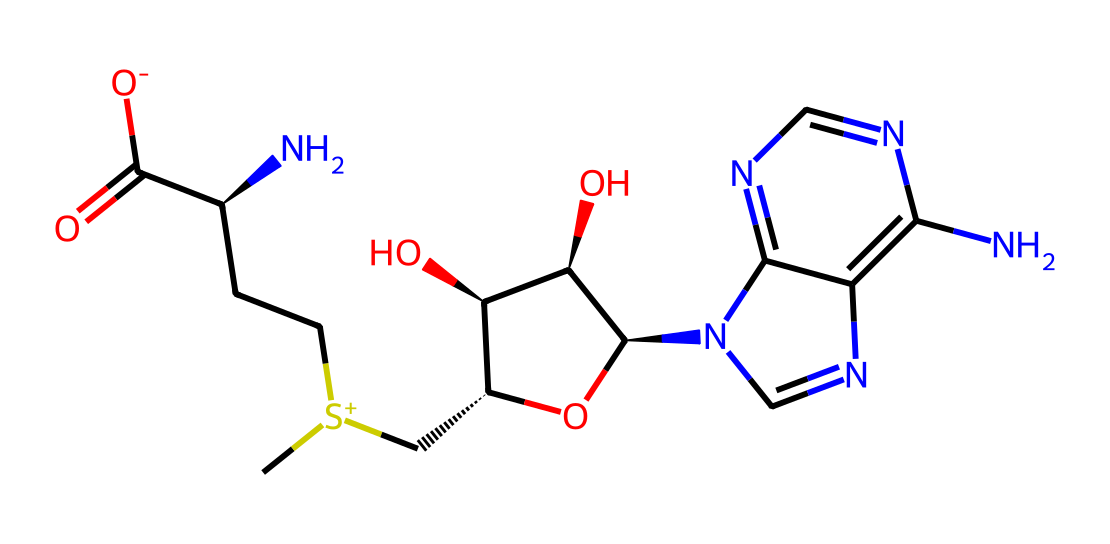What is the number of carbon atoms in S-Adenosyl methionine? By analyzing the provided SMILES representation, we can identify the carbon atoms (C). Counting each instance in the structure leads to a total of 12 carbon atoms.
Answer: 12 How many nitrogen atoms are present in the molecule? The SMILES representation includes multiple nitrogen (N) atoms. Counting these in the structure reveals that there are 6 nitrogen atoms.
Answer: 6 What type of functional group is featured in S-Adenosyl methionine related to sulfur? Observing the structure, we note the presence of a positively charged sulfur atom connected to a carbon and two methyl groups. This indicates the presence of a sulfonium group.
Answer: sulfonium What is the molecular weight of S-Adenosyl methionine? By summing the atomic weights of all atoms represented in the SMILES, the calculated molecular weight of the compound is approximately 399.5 g/mol.
Answer: 399.5 g/mol Which part of the chemical is primarily responsible for its role in methylation reactions? The sulfonium ion (the positively charged sulfur with methyl groups) is crucial for transferring methyl groups in biochemical reactions, thus indicating its role in methylation processes.
Answer: sulfonium ion Does S-Adenosyl methionine contain any hydroxyl (-OH) groups? A careful examination of the structure shows that two -OH groups are evident in the sugar part of the compound, confirming their presence.
Answer: 2 